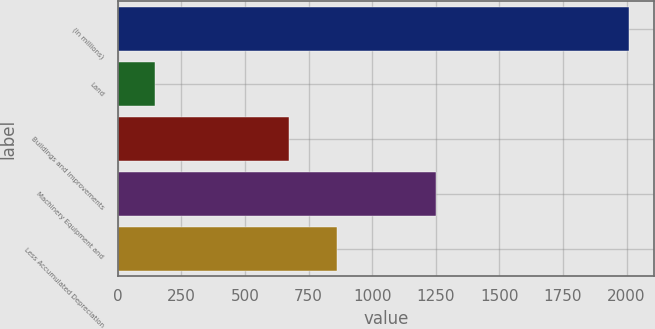<chart> <loc_0><loc_0><loc_500><loc_500><bar_chart><fcel>(In millions)<fcel>Land<fcel>Buildings and Improvements<fcel>Machinery Equipment and<fcel>Less Accumulated Depreciation<nl><fcel>2009<fcel>146.2<fcel>674.6<fcel>1251<fcel>860.88<nl></chart> 